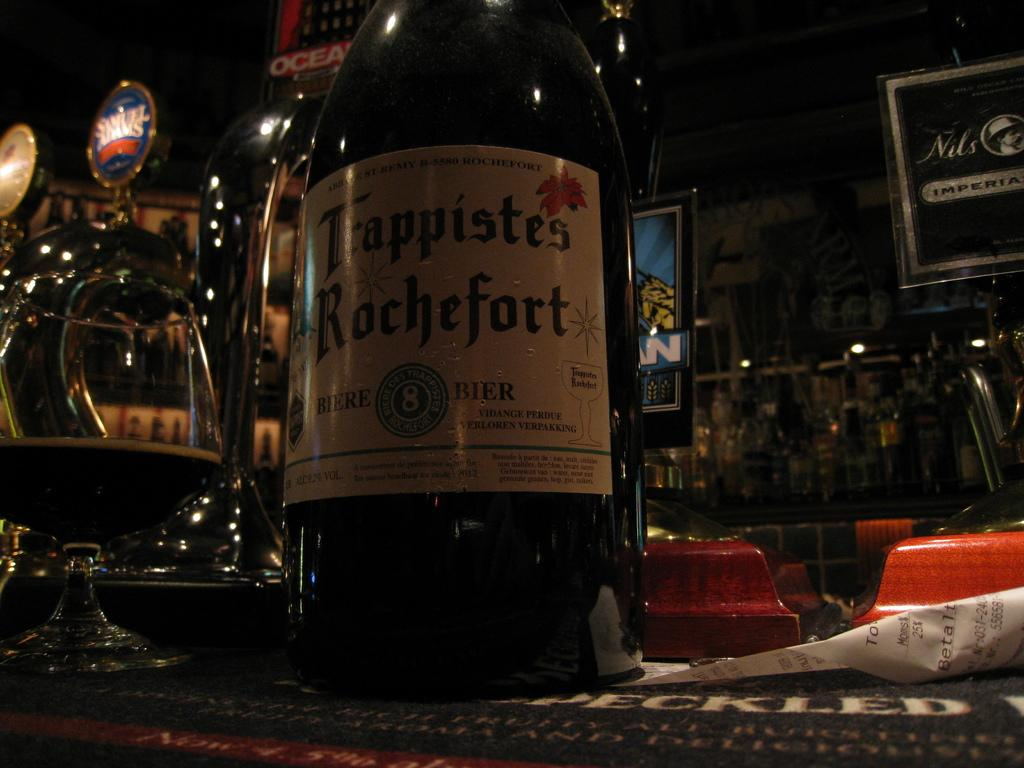<image>
Render a clear and concise summary of the photo. a bottle on a table called 'fappistes rochefort' in a bar 